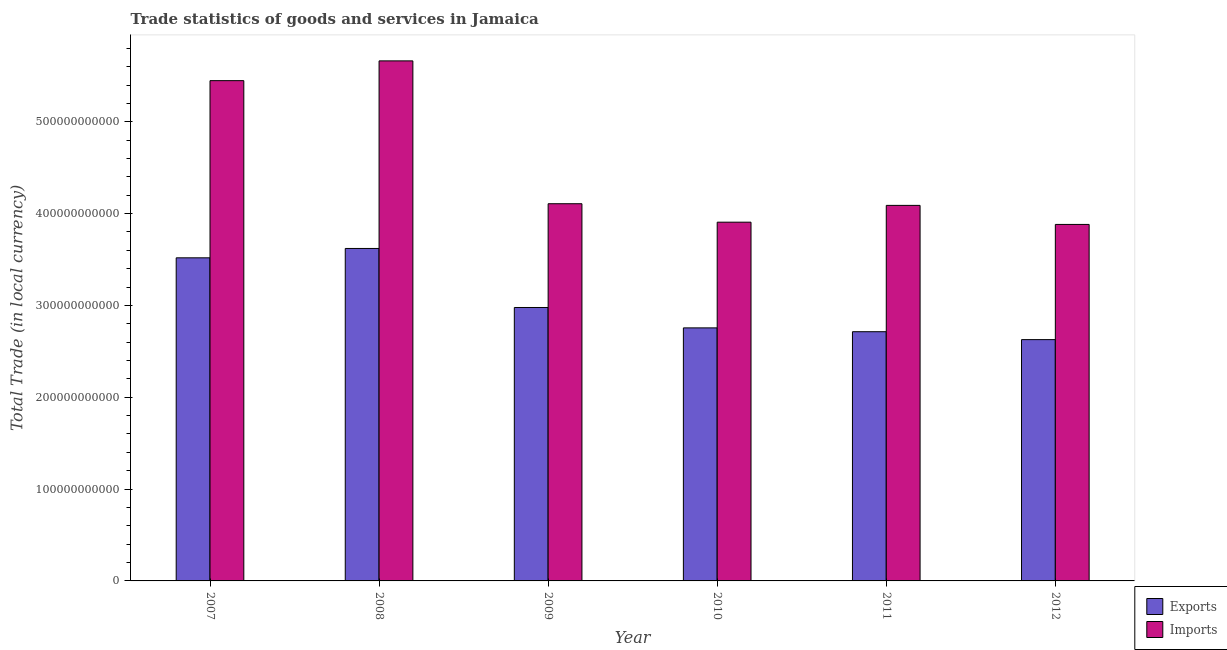How many groups of bars are there?
Give a very brief answer. 6. Are the number of bars per tick equal to the number of legend labels?
Make the answer very short. Yes. How many bars are there on the 5th tick from the right?
Offer a terse response. 2. What is the label of the 2nd group of bars from the left?
Give a very brief answer. 2008. In how many cases, is the number of bars for a given year not equal to the number of legend labels?
Offer a terse response. 0. What is the export of goods and services in 2010?
Provide a succinct answer. 2.76e+11. Across all years, what is the maximum export of goods and services?
Provide a succinct answer. 3.62e+11. Across all years, what is the minimum export of goods and services?
Make the answer very short. 2.63e+11. What is the total imports of goods and services in the graph?
Offer a very short reply. 2.71e+12. What is the difference between the imports of goods and services in 2007 and that in 2012?
Your answer should be very brief. 1.57e+11. What is the difference between the export of goods and services in 2009 and the imports of goods and services in 2007?
Give a very brief answer. -5.41e+1. What is the average imports of goods and services per year?
Provide a short and direct response. 4.52e+11. In the year 2010, what is the difference between the export of goods and services and imports of goods and services?
Provide a short and direct response. 0. What is the ratio of the imports of goods and services in 2007 to that in 2012?
Your answer should be compact. 1.4. Is the difference between the imports of goods and services in 2008 and 2012 greater than the difference between the export of goods and services in 2008 and 2012?
Provide a short and direct response. No. What is the difference between the highest and the second highest export of goods and services?
Offer a very short reply. 1.02e+1. What is the difference between the highest and the lowest export of goods and services?
Your response must be concise. 9.93e+1. What does the 1st bar from the left in 2008 represents?
Your answer should be very brief. Exports. What does the 1st bar from the right in 2007 represents?
Your answer should be very brief. Imports. What is the difference between two consecutive major ticks on the Y-axis?
Your answer should be compact. 1.00e+11. Are the values on the major ticks of Y-axis written in scientific E-notation?
Your answer should be very brief. No. Does the graph contain any zero values?
Provide a short and direct response. No. Where does the legend appear in the graph?
Keep it short and to the point. Bottom right. How are the legend labels stacked?
Offer a terse response. Vertical. What is the title of the graph?
Ensure brevity in your answer.  Trade statistics of goods and services in Jamaica. Does "Non-resident workers" appear as one of the legend labels in the graph?
Provide a short and direct response. No. What is the label or title of the X-axis?
Your response must be concise. Year. What is the label or title of the Y-axis?
Your answer should be compact. Total Trade (in local currency). What is the Total Trade (in local currency) in Exports in 2007?
Offer a very short reply. 3.52e+11. What is the Total Trade (in local currency) of Imports in 2007?
Keep it short and to the point. 5.45e+11. What is the Total Trade (in local currency) of Exports in 2008?
Keep it short and to the point. 3.62e+11. What is the Total Trade (in local currency) in Imports in 2008?
Make the answer very short. 5.66e+11. What is the Total Trade (in local currency) of Exports in 2009?
Give a very brief answer. 2.98e+11. What is the Total Trade (in local currency) of Imports in 2009?
Provide a succinct answer. 4.11e+11. What is the Total Trade (in local currency) in Exports in 2010?
Your answer should be very brief. 2.76e+11. What is the Total Trade (in local currency) in Imports in 2010?
Ensure brevity in your answer.  3.91e+11. What is the Total Trade (in local currency) in Exports in 2011?
Offer a very short reply. 2.71e+11. What is the Total Trade (in local currency) in Imports in 2011?
Provide a succinct answer. 4.09e+11. What is the Total Trade (in local currency) of Exports in 2012?
Keep it short and to the point. 2.63e+11. What is the Total Trade (in local currency) of Imports in 2012?
Give a very brief answer. 3.88e+11. Across all years, what is the maximum Total Trade (in local currency) in Exports?
Give a very brief answer. 3.62e+11. Across all years, what is the maximum Total Trade (in local currency) of Imports?
Your response must be concise. 5.66e+11. Across all years, what is the minimum Total Trade (in local currency) of Exports?
Your answer should be very brief. 2.63e+11. Across all years, what is the minimum Total Trade (in local currency) in Imports?
Provide a short and direct response. 3.88e+11. What is the total Total Trade (in local currency) of Exports in the graph?
Provide a succinct answer. 1.82e+12. What is the total Total Trade (in local currency) of Imports in the graph?
Provide a short and direct response. 2.71e+12. What is the difference between the Total Trade (in local currency) of Exports in 2007 and that in 2008?
Your response must be concise. -1.02e+1. What is the difference between the Total Trade (in local currency) of Imports in 2007 and that in 2008?
Ensure brevity in your answer.  -2.15e+1. What is the difference between the Total Trade (in local currency) of Exports in 2007 and that in 2009?
Give a very brief answer. 5.41e+1. What is the difference between the Total Trade (in local currency) in Imports in 2007 and that in 2009?
Your answer should be very brief. 1.34e+11. What is the difference between the Total Trade (in local currency) of Exports in 2007 and that in 2010?
Offer a terse response. 7.63e+1. What is the difference between the Total Trade (in local currency) in Imports in 2007 and that in 2010?
Provide a succinct answer. 1.54e+11. What is the difference between the Total Trade (in local currency) of Exports in 2007 and that in 2011?
Ensure brevity in your answer.  8.05e+1. What is the difference between the Total Trade (in local currency) of Imports in 2007 and that in 2011?
Give a very brief answer. 1.36e+11. What is the difference between the Total Trade (in local currency) in Exports in 2007 and that in 2012?
Provide a short and direct response. 8.91e+1. What is the difference between the Total Trade (in local currency) in Imports in 2007 and that in 2012?
Offer a terse response. 1.57e+11. What is the difference between the Total Trade (in local currency) of Exports in 2008 and that in 2009?
Your answer should be compact. 6.43e+1. What is the difference between the Total Trade (in local currency) in Imports in 2008 and that in 2009?
Make the answer very short. 1.56e+11. What is the difference between the Total Trade (in local currency) of Exports in 2008 and that in 2010?
Your answer should be very brief. 8.65e+1. What is the difference between the Total Trade (in local currency) in Imports in 2008 and that in 2010?
Keep it short and to the point. 1.76e+11. What is the difference between the Total Trade (in local currency) in Exports in 2008 and that in 2011?
Offer a very short reply. 9.07e+1. What is the difference between the Total Trade (in local currency) in Imports in 2008 and that in 2011?
Offer a terse response. 1.57e+11. What is the difference between the Total Trade (in local currency) in Exports in 2008 and that in 2012?
Keep it short and to the point. 9.93e+1. What is the difference between the Total Trade (in local currency) of Imports in 2008 and that in 2012?
Offer a terse response. 1.78e+11. What is the difference between the Total Trade (in local currency) in Exports in 2009 and that in 2010?
Provide a succinct answer. 2.22e+1. What is the difference between the Total Trade (in local currency) of Imports in 2009 and that in 2010?
Provide a succinct answer. 2.01e+1. What is the difference between the Total Trade (in local currency) in Exports in 2009 and that in 2011?
Offer a terse response. 2.64e+1. What is the difference between the Total Trade (in local currency) of Imports in 2009 and that in 2011?
Your answer should be very brief. 1.80e+09. What is the difference between the Total Trade (in local currency) of Exports in 2009 and that in 2012?
Offer a terse response. 3.50e+1. What is the difference between the Total Trade (in local currency) of Imports in 2009 and that in 2012?
Give a very brief answer. 2.25e+1. What is the difference between the Total Trade (in local currency) of Exports in 2010 and that in 2011?
Offer a terse response. 4.18e+09. What is the difference between the Total Trade (in local currency) of Imports in 2010 and that in 2011?
Make the answer very short. -1.83e+1. What is the difference between the Total Trade (in local currency) of Exports in 2010 and that in 2012?
Give a very brief answer. 1.28e+1. What is the difference between the Total Trade (in local currency) of Imports in 2010 and that in 2012?
Provide a succinct answer. 2.44e+09. What is the difference between the Total Trade (in local currency) of Exports in 2011 and that in 2012?
Offer a terse response. 8.60e+09. What is the difference between the Total Trade (in local currency) in Imports in 2011 and that in 2012?
Provide a succinct answer. 2.07e+1. What is the difference between the Total Trade (in local currency) of Exports in 2007 and the Total Trade (in local currency) of Imports in 2008?
Your answer should be very brief. -2.14e+11. What is the difference between the Total Trade (in local currency) of Exports in 2007 and the Total Trade (in local currency) of Imports in 2009?
Your response must be concise. -5.89e+1. What is the difference between the Total Trade (in local currency) in Exports in 2007 and the Total Trade (in local currency) in Imports in 2010?
Provide a short and direct response. -3.88e+1. What is the difference between the Total Trade (in local currency) in Exports in 2007 and the Total Trade (in local currency) in Imports in 2011?
Make the answer very short. -5.71e+1. What is the difference between the Total Trade (in local currency) of Exports in 2007 and the Total Trade (in local currency) of Imports in 2012?
Offer a very short reply. -3.64e+1. What is the difference between the Total Trade (in local currency) of Exports in 2008 and the Total Trade (in local currency) of Imports in 2009?
Keep it short and to the point. -4.87e+1. What is the difference between the Total Trade (in local currency) in Exports in 2008 and the Total Trade (in local currency) in Imports in 2010?
Keep it short and to the point. -2.86e+1. What is the difference between the Total Trade (in local currency) of Exports in 2008 and the Total Trade (in local currency) of Imports in 2011?
Your answer should be very brief. -4.69e+1. What is the difference between the Total Trade (in local currency) of Exports in 2008 and the Total Trade (in local currency) of Imports in 2012?
Offer a terse response. -2.62e+1. What is the difference between the Total Trade (in local currency) in Exports in 2009 and the Total Trade (in local currency) in Imports in 2010?
Provide a short and direct response. -9.29e+1. What is the difference between the Total Trade (in local currency) in Exports in 2009 and the Total Trade (in local currency) in Imports in 2011?
Give a very brief answer. -1.11e+11. What is the difference between the Total Trade (in local currency) of Exports in 2009 and the Total Trade (in local currency) of Imports in 2012?
Offer a very short reply. -9.05e+1. What is the difference between the Total Trade (in local currency) of Exports in 2010 and the Total Trade (in local currency) of Imports in 2011?
Keep it short and to the point. -1.33e+11. What is the difference between the Total Trade (in local currency) in Exports in 2010 and the Total Trade (in local currency) in Imports in 2012?
Your answer should be very brief. -1.13e+11. What is the difference between the Total Trade (in local currency) of Exports in 2011 and the Total Trade (in local currency) of Imports in 2012?
Give a very brief answer. -1.17e+11. What is the average Total Trade (in local currency) in Exports per year?
Provide a short and direct response. 3.04e+11. What is the average Total Trade (in local currency) in Imports per year?
Keep it short and to the point. 4.52e+11. In the year 2007, what is the difference between the Total Trade (in local currency) of Exports and Total Trade (in local currency) of Imports?
Offer a very short reply. -1.93e+11. In the year 2008, what is the difference between the Total Trade (in local currency) of Exports and Total Trade (in local currency) of Imports?
Provide a short and direct response. -2.04e+11. In the year 2009, what is the difference between the Total Trade (in local currency) in Exports and Total Trade (in local currency) in Imports?
Give a very brief answer. -1.13e+11. In the year 2010, what is the difference between the Total Trade (in local currency) of Exports and Total Trade (in local currency) of Imports?
Provide a short and direct response. -1.15e+11. In the year 2011, what is the difference between the Total Trade (in local currency) of Exports and Total Trade (in local currency) of Imports?
Your response must be concise. -1.38e+11. In the year 2012, what is the difference between the Total Trade (in local currency) of Exports and Total Trade (in local currency) of Imports?
Keep it short and to the point. -1.25e+11. What is the ratio of the Total Trade (in local currency) of Exports in 2007 to that in 2008?
Your answer should be compact. 0.97. What is the ratio of the Total Trade (in local currency) in Imports in 2007 to that in 2008?
Your answer should be very brief. 0.96. What is the ratio of the Total Trade (in local currency) in Exports in 2007 to that in 2009?
Give a very brief answer. 1.18. What is the ratio of the Total Trade (in local currency) in Imports in 2007 to that in 2009?
Your response must be concise. 1.33. What is the ratio of the Total Trade (in local currency) of Exports in 2007 to that in 2010?
Ensure brevity in your answer.  1.28. What is the ratio of the Total Trade (in local currency) of Imports in 2007 to that in 2010?
Your response must be concise. 1.39. What is the ratio of the Total Trade (in local currency) in Exports in 2007 to that in 2011?
Ensure brevity in your answer.  1.3. What is the ratio of the Total Trade (in local currency) in Imports in 2007 to that in 2011?
Your answer should be very brief. 1.33. What is the ratio of the Total Trade (in local currency) of Exports in 2007 to that in 2012?
Give a very brief answer. 1.34. What is the ratio of the Total Trade (in local currency) in Imports in 2007 to that in 2012?
Give a very brief answer. 1.4. What is the ratio of the Total Trade (in local currency) in Exports in 2008 to that in 2009?
Ensure brevity in your answer.  1.22. What is the ratio of the Total Trade (in local currency) of Imports in 2008 to that in 2009?
Ensure brevity in your answer.  1.38. What is the ratio of the Total Trade (in local currency) of Exports in 2008 to that in 2010?
Provide a short and direct response. 1.31. What is the ratio of the Total Trade (in local currency) of Imports in 2008 to that in 2010?
Ensure brevity in your answer.  1.45. What is the ratio of the Total Trade (in local currency) of Exports in 2008 to that in 2011?
Provide a short and direct response. 1.33. What is the ratio of the Total Trade (in local currency) in Imports in 2008 to that in 2011?
Your answer should be compact. 1.38. What is the ratio of the Total Trade (in local currency) of Exports in 2008 to that in 2012?
Offer a terse response. 1.38. What is the ratio of the Total Trade (in local currency) in Imports in 2008 to that in 2012?
Offer a very short reply. 1.46. What is the ratio of the Total Trade (in local currency) in Exports in 2009 to that in 2010?
Your response must be concise. 1.08. What is the ratio of the Total Trade (in local currency) in Imports in 2009 to that in 2010?
Make the answer very short. 1.05. What is the ratio of the Total Trade (in local currency) in Exports in 2009 to that in 2011?
Your response must be concise. 1.1. What is the ratio of the Total Trade (in local currency) in Exports in 2009 to that in 2012?
Offer a terse response. 1.13. What is the ratio of the Total Trade (in local currency) of Imports in 2009 to that in 2012?
Provide a short and direct response. 1.06. What is the ratio of the Total Trade (in local currency) of Exports in 2010 to that in 2011?
Offer a terse response. 1.02. What is the ratio of the Total Trade (in local currency) in Imports in 2010 to that in 2011?
Make the answer very short. 0.96. What is the ratio of the Total Trade (in local currency) of Exports in 2010 to that in 2012?
Make the answer very short. 1.05. What is the ratio of the Total Trade (in local currency) in Imports in 2010 to that in 2012?
Your answer should be very brief. 1.01. What is the ratio of the Total Trade (in local currency) in Exports in 2011 to that in 2012?
Give a very brief answer. 1.03. What is the ratio of the Total Trade (in local currency) of Imports in 2011 to that in 2012?
Your response must be concise. 1.05. What is the difference between the highest and the second highest Total Trade (in local currency) in Exports?
Offer a terse response. 1.02e+1. What is the difference between the highest and the second highest Total Trade (in local currency) of Imports?
Keep it short and to the point. 2.15e+1. What is the difference between the highest and the lowest Total Trade (in local currency) of Exports?
Ensure brevity in your answer.  9.93e+1. What is the difference between the highest and the lowest Total Trade (in local currency) in Imports?
Your answer should be compact. 1.78e+11. 